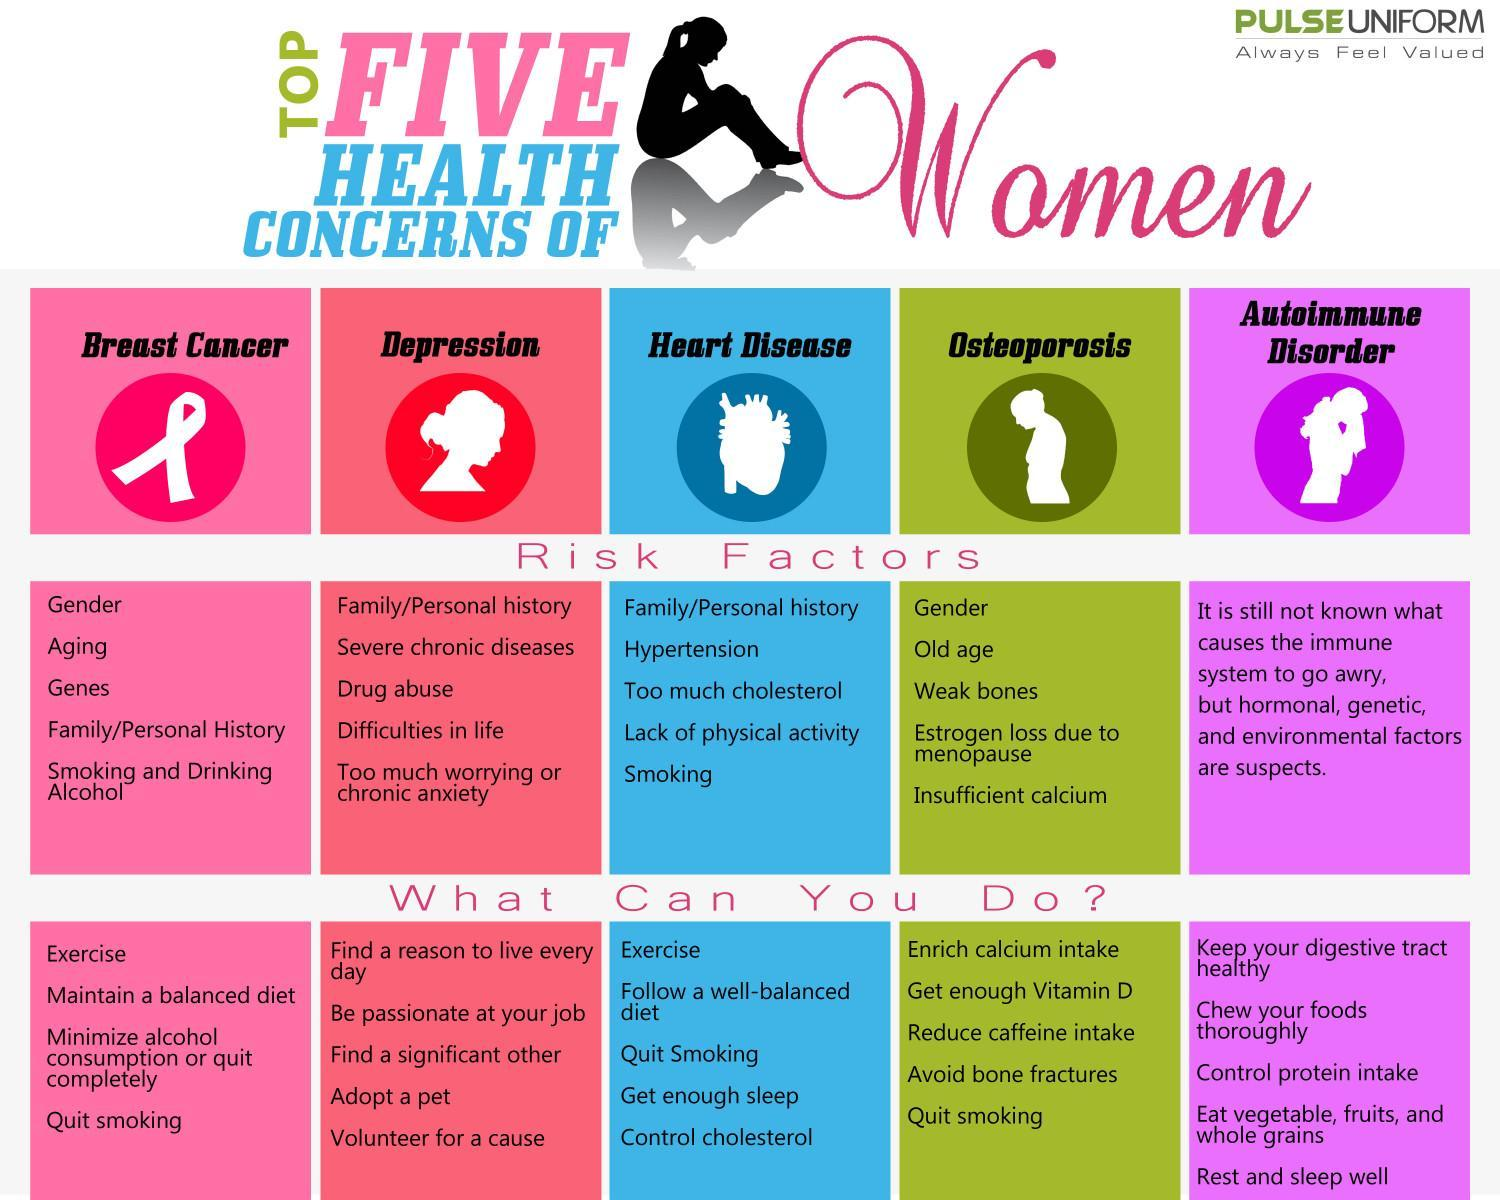Which health concerns have family history as a risk factor?
Answer the question with a short phrase. Depression, Heart Disease, Breast Cancer Which diseases can be kept at bay with exercise? Breast Cancer, Heart Disease Which habit should be quit to reduce chances of breast cancer, heart disease, or osteoporosis? Smoking Which is common risk factor for breast cancer and osteoporosis? Gender 